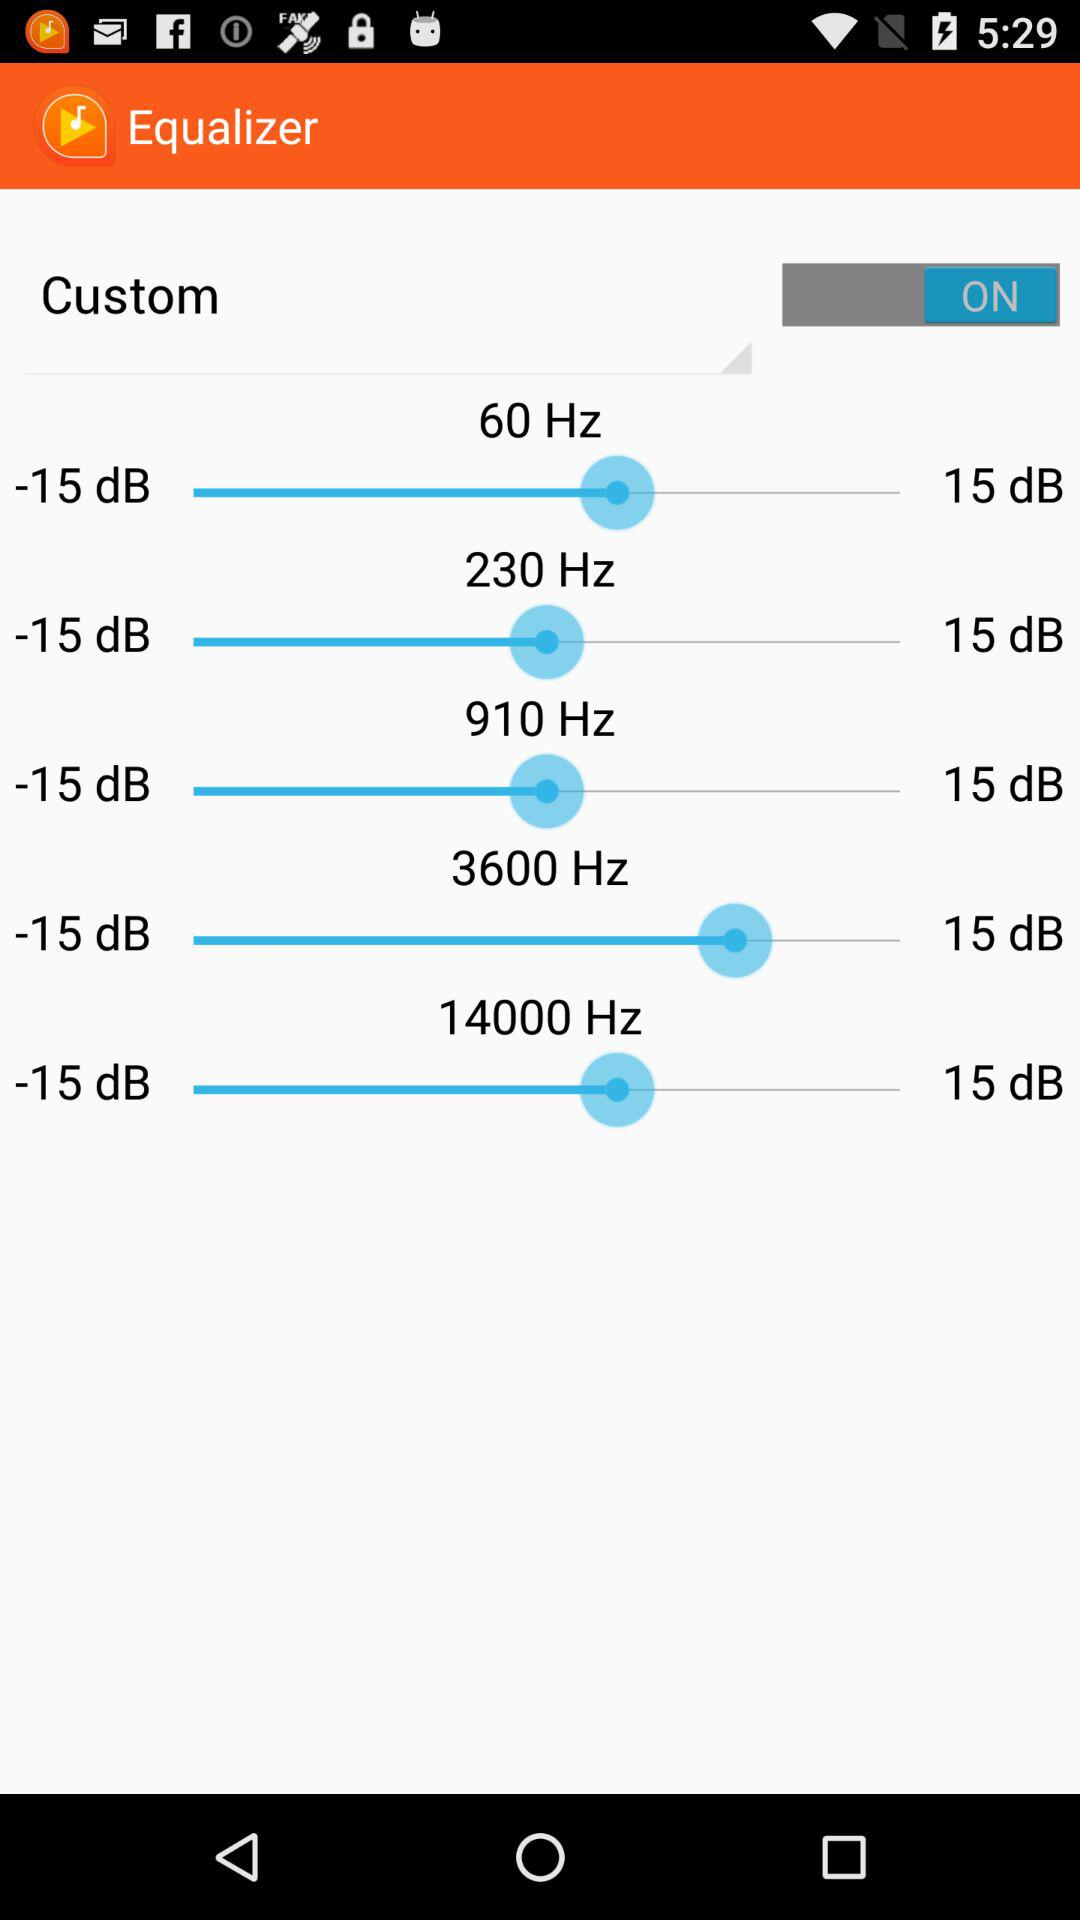What is the application name? The name of the application is "Equalizer". 